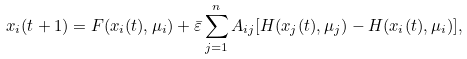<formula> <loc_0><loc_0><loc_500><loc_500>x _ { i } ( t + 1 ) = F ( x _ { i } ( t ) , \mu _ { i } ) + \bar { \varepsilon } \sum _ { j = 1 } ^ { n } A _ { i j } [ H ( x _ { j } ( t ) , \mu _ { j } ) - H ( x _ { i } ( t ) , \mu _ { i } ) ] ,</formula> 